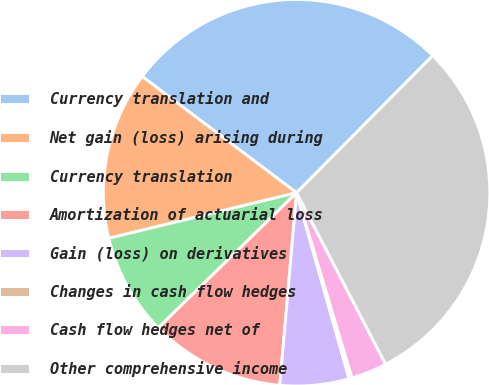Convert chart. <chart><loc_0><loc_0><loc_500><loc_500><pie_chart><fcel>Currency translation and<fcel>Net gain (loss) arising during<fcel>Currency translation<fcel>Amortization of actuarial loss<fcel>Gain (loss) on derivatives<fcel>Changes in cash flow hedges<fcel>Cash flow hedges net of<fcel>Other comprehensive income<nl><fcel>27.17%<fcel>14.06%<fcel>8.53%<fcel>11.3%<fcel>5.77%<fcel>0.24%<fcel>3.0%<fcel>29.93%<nl></chart> 